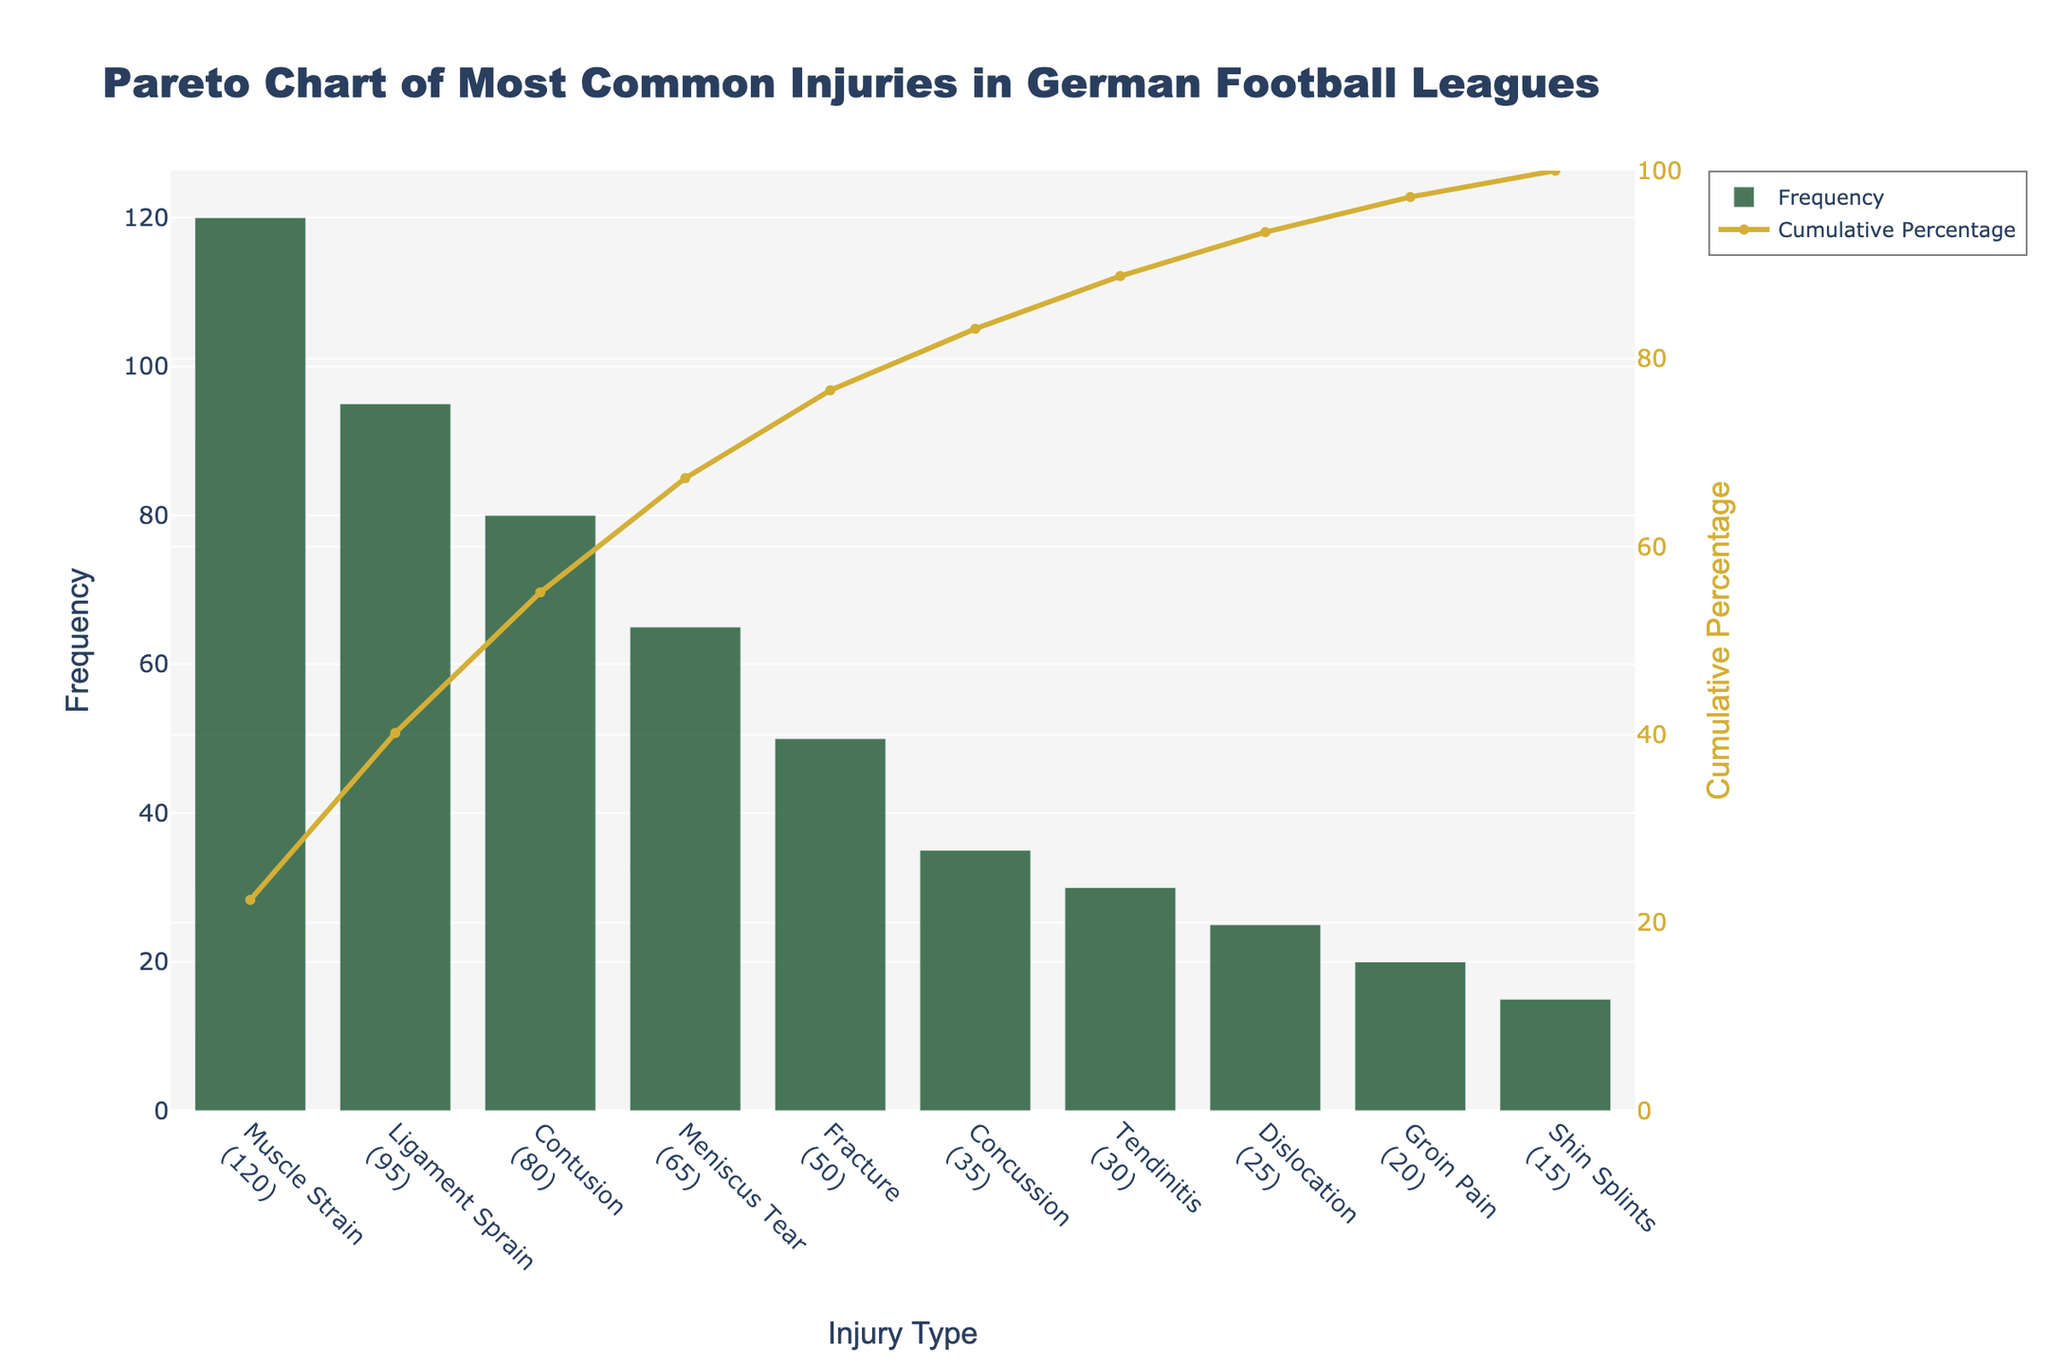What is the most common injury type according to the chart? The highest bar represents the most common injury type, which is "Muscle Strain." Its frequency is the highest among other injuries.
Answer: Muscle Strain What percentage of injuries are accounted for by muscle strains and ligament sprains combined? Muscle Strains account for 120 injuries and Ligament Sprains account for 95. Adding these, we get 120 + 95 = 215. The cumulative percentage at Ligament Sprain is about 44%.
Answer: 44% How many injury types contribute to 80% of the total injuries? By looking at the cumulative percentage line, we find that the first 4 injury types (Muscle Strain, Ligament Sprain, Contusion, Meniscus Tear) cover up to about 82%.
Answer: 4 What is the cumulative percentage of the top three most common injury types? The top three most common injury types are Muscle Strain, Ligament Sprain, and Contusion (120 + 95 + 80 = 295 injuries). The cumulative percentage at Contusion is approximately 72%.
Answer: 72% Is the cumulative percentage for fractures higher or lower than 50%? The cumulative percentage line shows that Fracture's cumulative percentage is below the 50% mark. It falls around 48%.
Answer: Lower What are the frequencies of the two least common injuries shown in the chart? The two least common injuries are "Groin Pain" (20) and "Shin Splints" (15).
Answer: 20 and 15 Which injury type marks the 50% threshold in the cumulative percentage line? The cumulative percentage lines intersect the 50% threshold just before the Meniscus Tear, indicating it's one of the first four most common injuries.
Answer: Meniscus Tear How many injuries are accounted for by the three least common injury types? Adding the frequencies of Tendinitis (30), Dislocation (25), Groin Pain (20), and Shin Splints (15) gives 30 + 25 + 20 + 15 = 90 injuries.
Answer: 90 